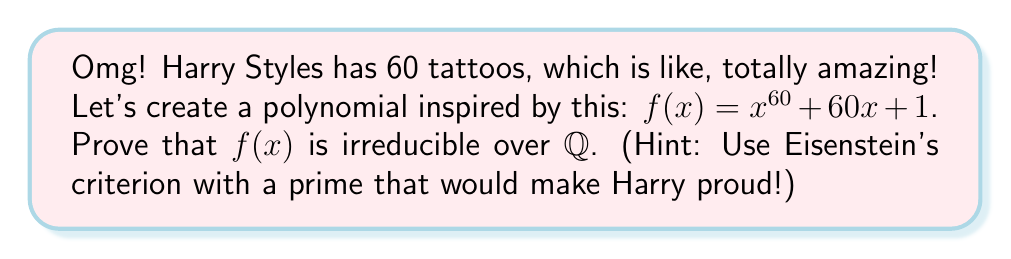Show me your answer to this math problem. Let's prove this step-by-step, using Eisenstein's criterion:

1) First, recall Eisenstein's criterion: If there exists a prime $p$ such that:
   a) $p$ divides all coefficients except the leading coefficient
   b) $p^2$ does not divide the constant term
   c) $p$ does not divide the leading coefficient
   Then the polynomial is irreducible over $\mathbb{Q}$.

2) Now, let's choose a prime that Harry would love. How about $p = 5$ (because One Direction had 5 members)?

3) Check the conditions:
   a) $5$ divides $60$ (the coefficient of $x$) and $1$ (the constant term)
   b) $5^2 = 25$ does not divide $1$ (the constant term)
   c) $5$ does not divide the leading coefficient (which is $1$)

4) All conditions of Eisenstein's criterion are satisfied!

5) Therefore, $f(x) = x^{60} + 60x + 1$ is irreducible over $\mathbb{Q}$.

Yay! We've proven it using a Harry-inspired prime! He'd be so proud!
Answer: $f(x)$ is irreducible over $\mathbb{Q}$ by Eisenstein's criterion with $p=5$. 